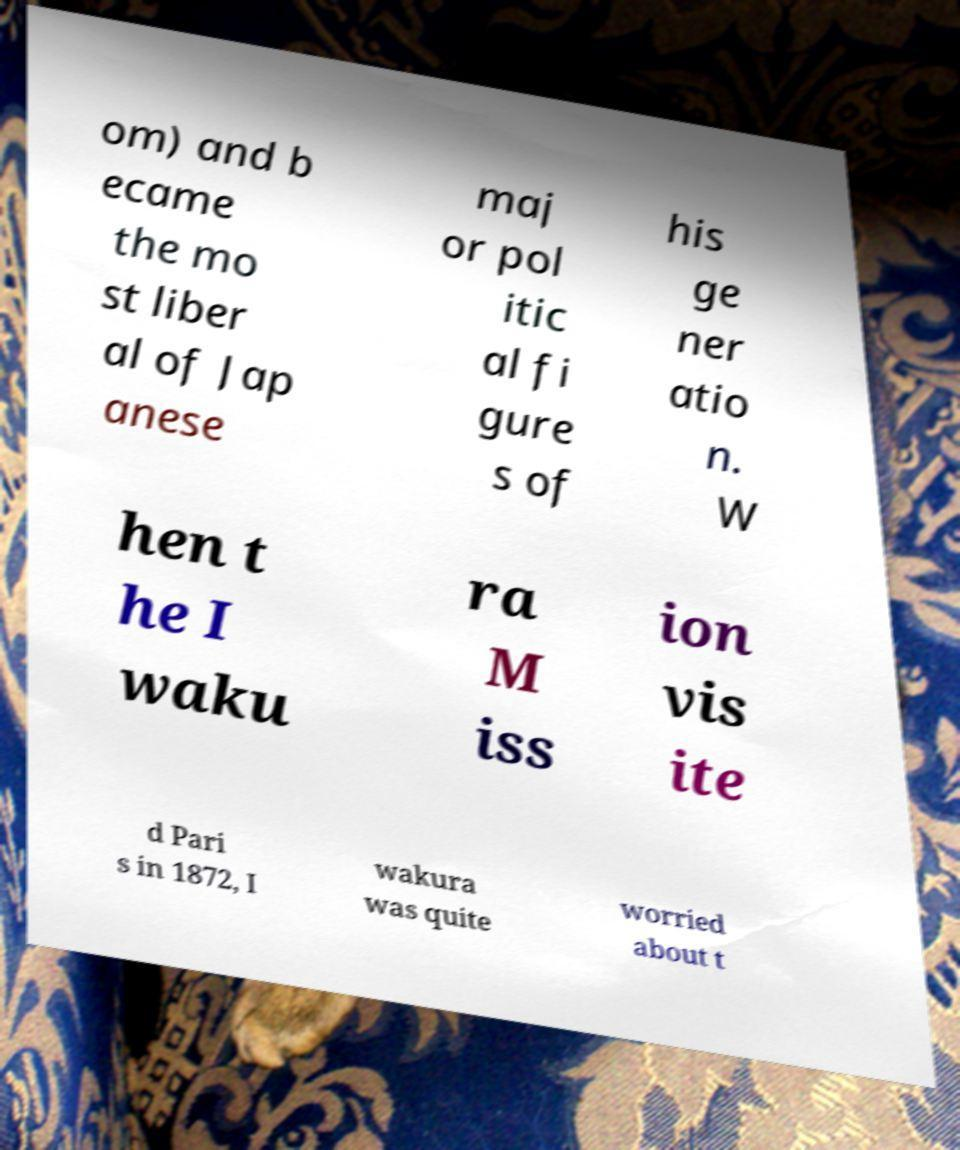Please read and relay the text visible in this image. What does it say? om) and b ecame the mo st liber al of Jap anese maj or pol itic al fi gure s of his ge ner atio n. W hen t he I waku ra M iss ion vis ite d Pari s in 1872, I wakura was quite worried about t 